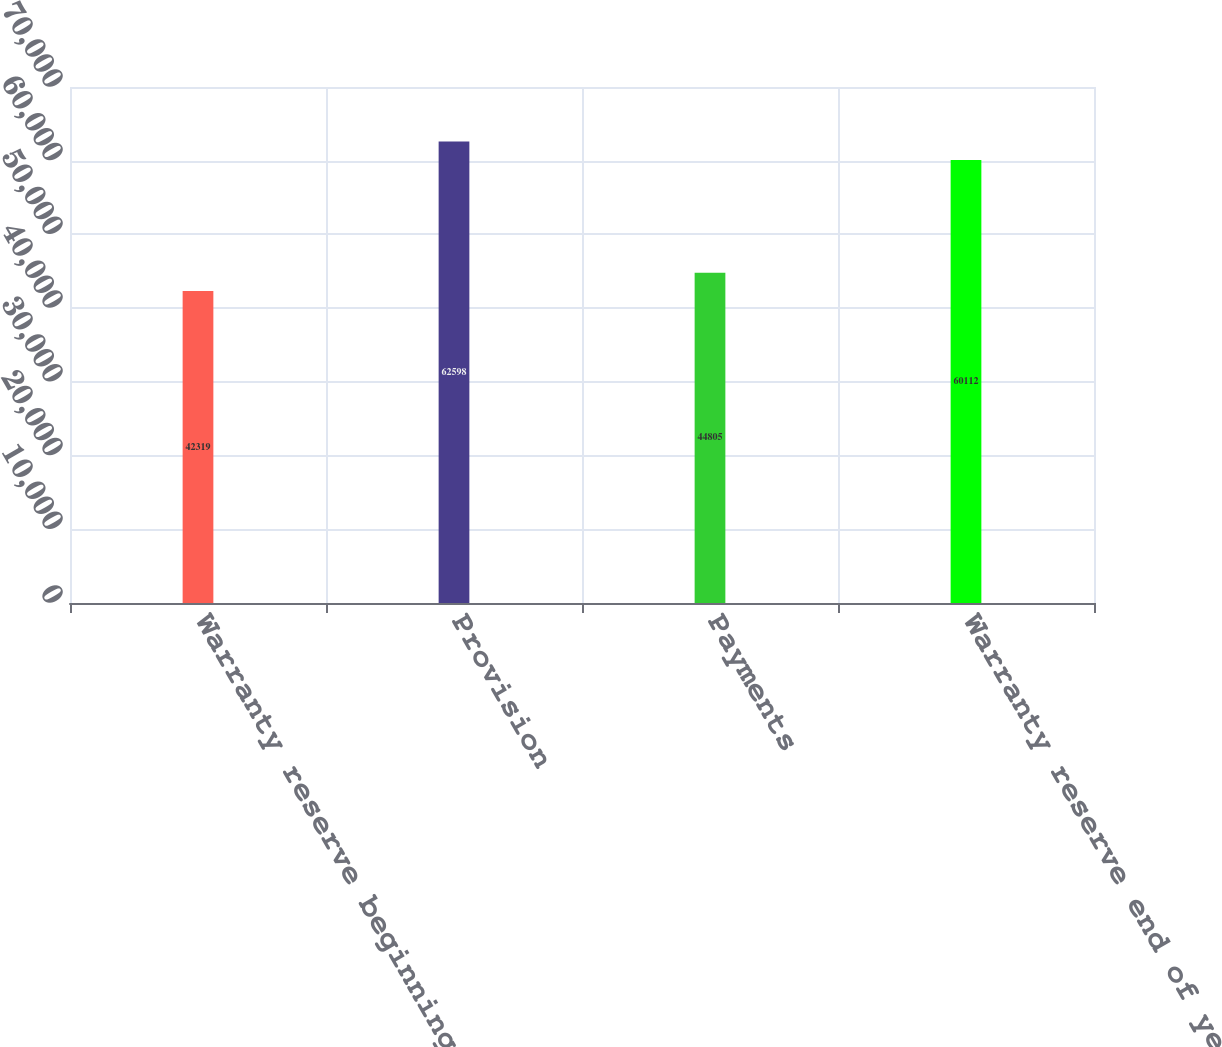<chart> <loc_0><loc_0><loc_500><loc_500><bar_chart><fcel>Warranty reserve beginning of<fcel>Provision<fcel>Payments<fcel>Warranty reserve end of year<nl><fcel>42319<fcel>62598<fcel>44805<fcel>60112<nl></chart> 